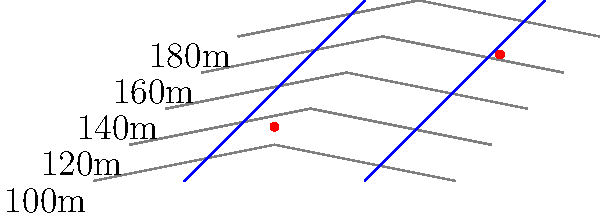Based on the topographical map provided, which of the two marked potential settlement sites (red dots) is more likely to have access to a stable water source for an ancient civilization? Explain your reasoning. To determine which potential settlement site has better access to a stable water source, we need to analyze the topographical map considering the following factors:

1. Proximity to rivers: 
   - The left site (100,30) is closer to the confluence of two rivers.
   - The right site (225,70) is near a single river but at a higher elevation.

2. Elevation and flood risk:
   - The left site is at a lower elevation (approximately 130m), which may be prone to flooding but ensures easier access to water.
   - The right site is at a higher elevation (approximately 165m), reducing flood risk but potentially making water access more difficult.

3. River flow direction:
   - Rivers typically flow from higher to lower elevations.
   - Both rivers appear to flow from top to bottom of the map.

4. Water reliability:
   - The confluence of two rivers near the left site suggests a more reliable and abundant water source.
   - The single river near the right site may be less reliable, especially during dry seasons.

5. Topography and water collection:
   - The left site is in a slight depression, which may collect and retain water more easily.
   - The right site is on a steeper slope, which may lead to faster water runoff.

Considering these factors, the left site (100,30) is more likely to have access to a stable water source due to its proximity to the confluence of two rivers, lower elevation for easier access, and potential for better water retention in the surrounding topography.
Answer: Left site (100,30) 